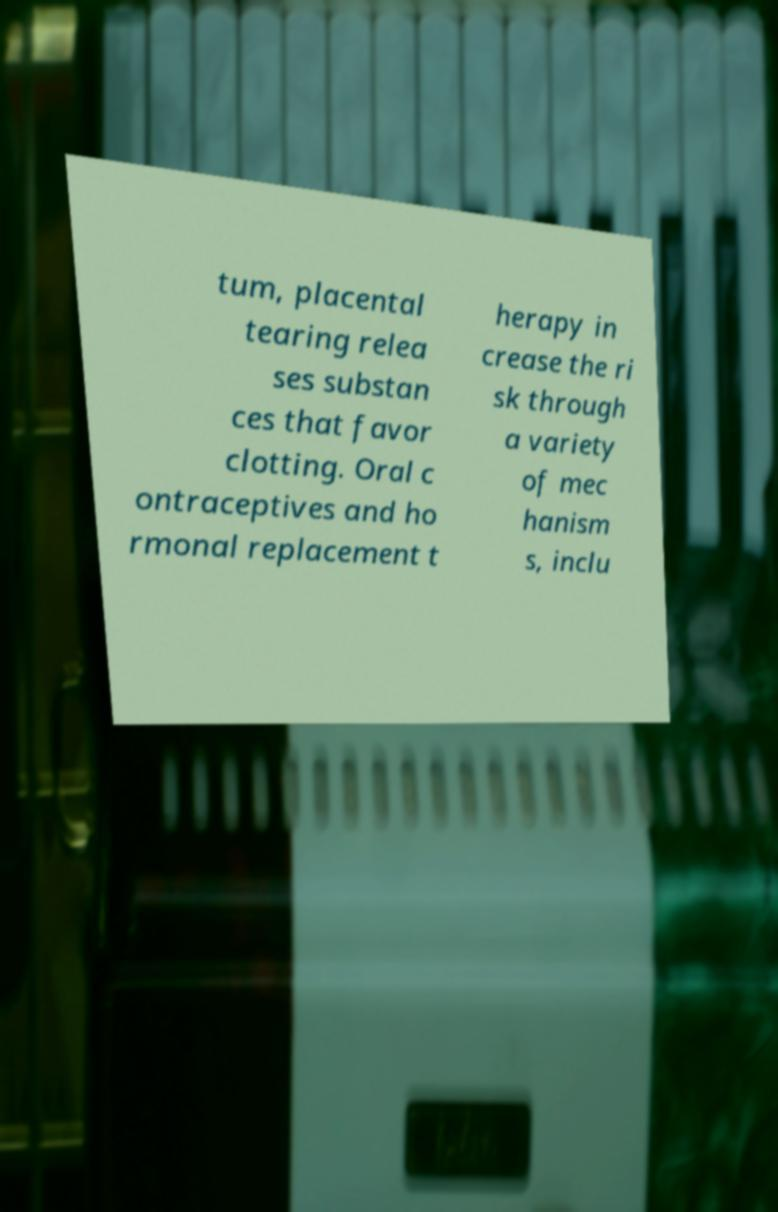What messages or text are displayed in this image? I need them in a readable, typed format. tum, placental tearing relea ses substan ces that favor clotting. Oral c ontraceptives and ho rmonal replacement t herapy in crease the ri sk through a variety of mec hanism s, inclu 